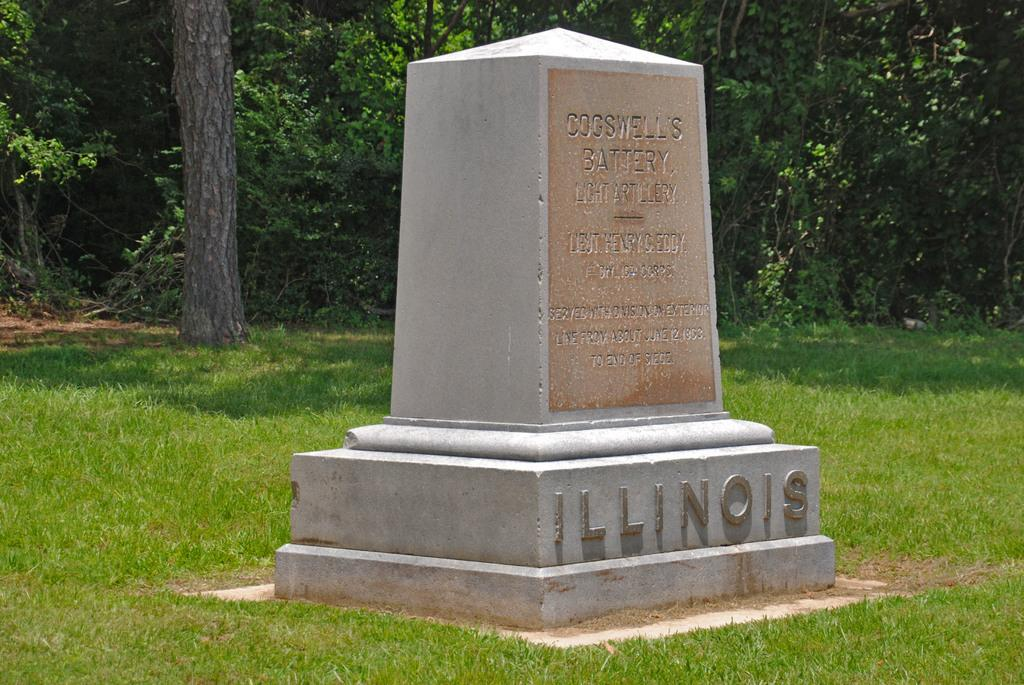What is located on the ground in the image? There is a memorial on the ground. What can be found on the memorial? There is text on the memorial. What type of vegetation is present on the ground? There is grass on the ground. What can be seen in the background of the image? There are trees in the background of the image. Is there a maid cleaning the memorial in the image? There is no maid present in the image, and the memorial is not being cleaned. 